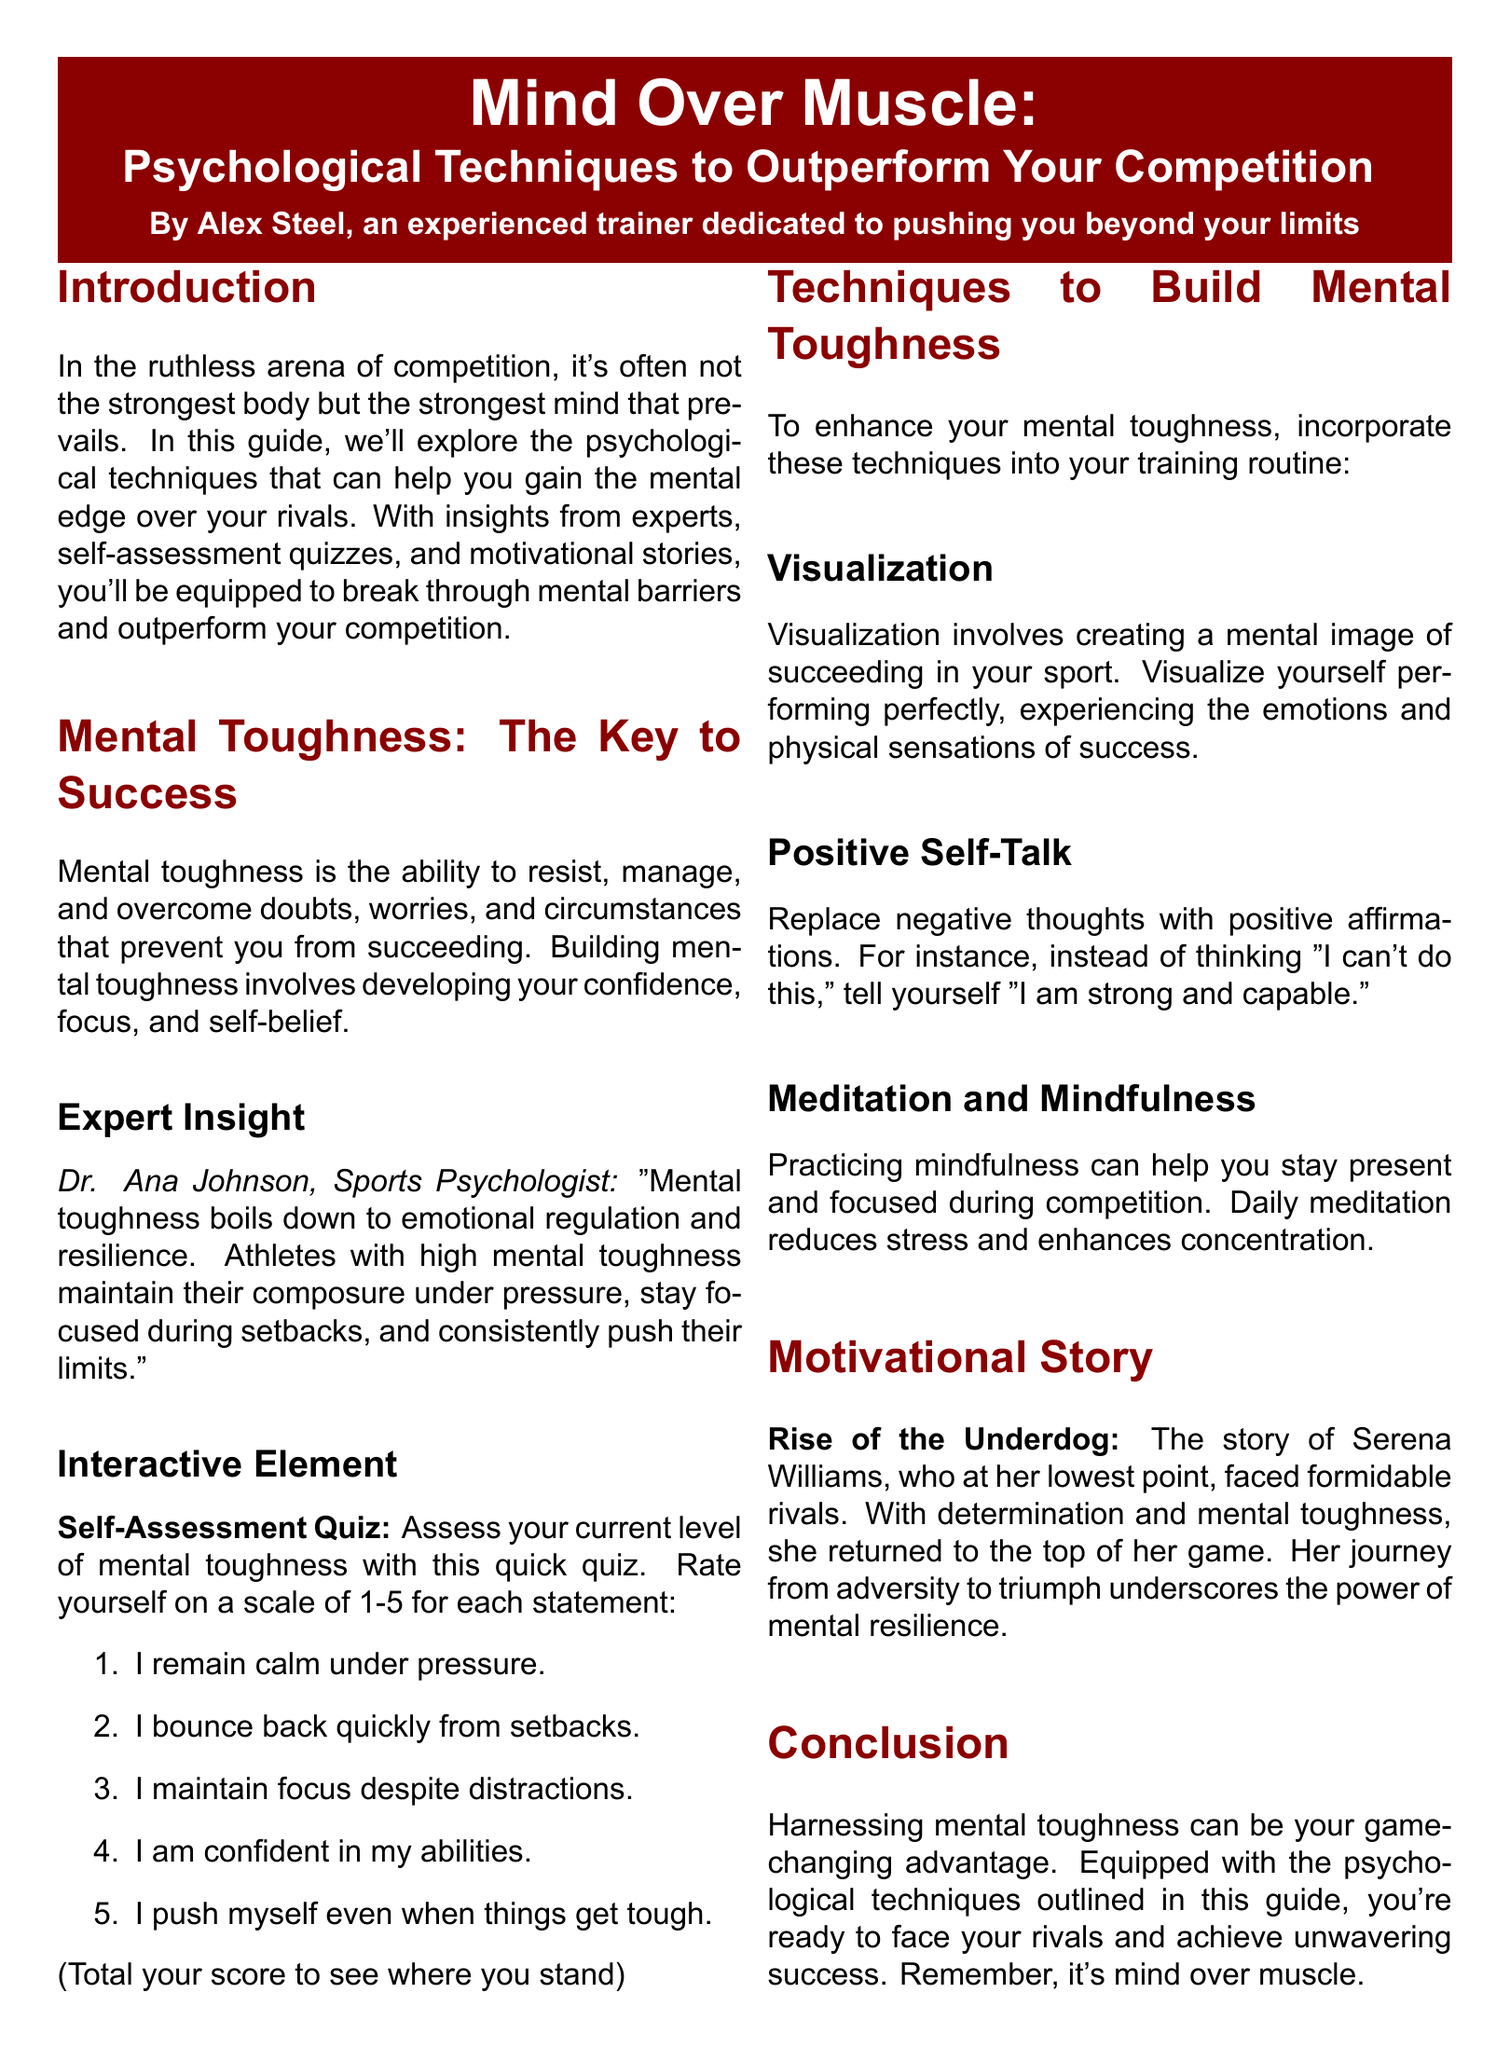What is the main title of the document? The main title is presented prominently at the top, outlining the document's focus on psychological techniques.
Answer: Mind Over Muscle: Psychological Techniques to Outperform Your Competition Who is the author of the document? The author is identified beneath the title, indicating their experience and dedication.
Answer: Alex Steel What is the self-assessment quiz based on? The quiz is designed to help assess current levels of mental toughness by rating various personal qualities.
Answer: Mental toughness What technique involves creating a mental image of success? This technique helps athletes visualize their performance and emotional state associated with success.
Answer: Visualization Which sports psychologist is quoted in the document? The expert insight provided includes the name of a well-known sports psychologist.
Answer: Dr. Ana Johnson What is the motivational story in the document about? The story highlights a famous athlete's journey from adversity to success, demonstrating mental resilience.
Answer: Rise of the Underdog How many statements are there in the self-assessment quiz? The number of statements allows for a quick assessment of mental toughness through self-rating.
Answer: Five What is one way to improve focus during competition? This technique is suggested to help athletes stay present and manage stress effectively.
Answer: Meditation and Mindfulness What does the document say mental toughness boils down to? It summarizes mental toughness in relation to emotional states and athlete performance under pressure.
Answer: Emotional regulation and resilience 